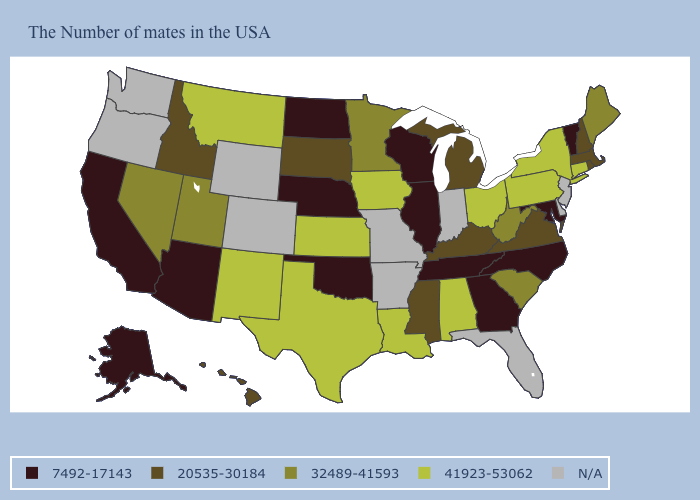Among the states that border Wyoming , which have the highest value?
Keep it brief. Montana. Name the states that have a value in the range N/A?
Write a very short answer. New Jersey, Delaware, Florida, Indiana, Missouri, Arkansas, Wyoming, Colorado, Washington, Oregon. What is the value of New York?
Quick response, please. 41923-53062. Does the map have missing data?
Short answer required. Yes. What is the value of Texas?
Concise answer only. 41923-53062. Name the states that have a value in the range 32489-41593?
Write a very short answer. Maine, South Carolina, West Virginia, Minnesota, Utah, Nevada. Among the states that border New Hampshire , does Massachusetts have the lowest value?
Concise answer only. No. Does Rhode Island have the highest value in the USA?
Short answer required. No. What is the value of Hawaii?
Give a very brief answer. 20535-30184. What is the value of Ohio?
Write a very short answer. 41923-53062. What is the lowest value in the Northeast?
Be succinct. 7492-17143. What is the lowest value in states that border Georgia?
Keep it brief. 7492-17143. Among the states that border Vermont , which have the highest value?
Keep it brief. New York. Does Nevada have the lowest value in the West?
Give a very brief answer. No. 